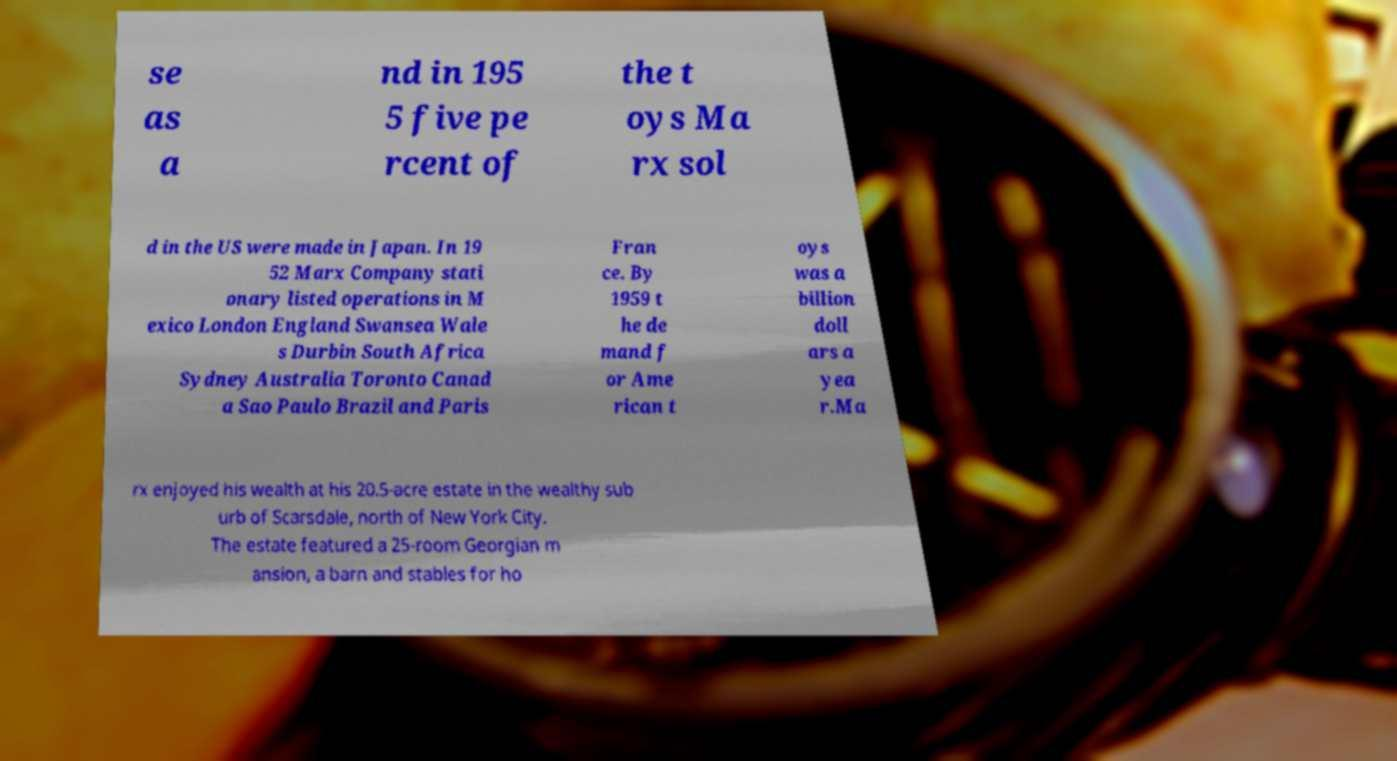What messages or text are displayed in this image? I need them in a readable, typed format. se as a nd in 195 5 five pe rcent of the t oys Ma rx sol d in the US were made in Japan. In 19 52 Marx Company stati onary listed operations in M exico London England Swansea Wale s Durbin South Africa Sydney Australia Toronto Canad a Sao Paulo Brazil and Paris Fran ce. By 1959 t he de mand f or Ame rican t oys was a billion doll ars a yea r.Ma rx enjoyed his wealth at his 20.5-acre estate in the wealthy sub urb of Scarsdale, north of New York City. The estate featured a 25-room Georgian m ansion, a barn and stables for ho 